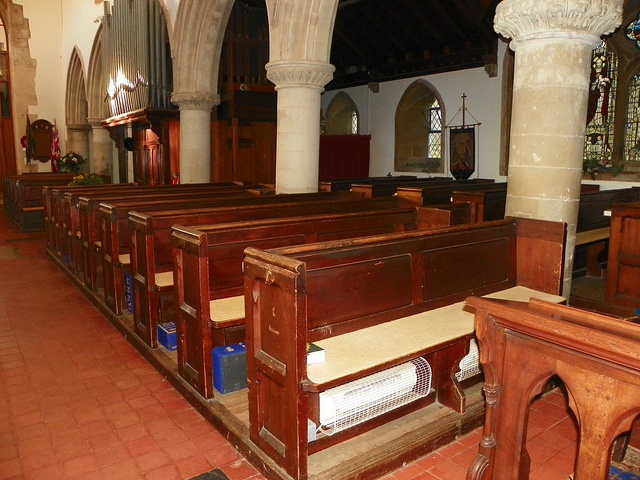Describe the objects in this image and their specific colors. I can see bench in maroon and tan tones, bench in maroon and brown tones, bench in maroon, brown, and tan tones, bench in maroon, black, and tan tones, and bench in maroon and brown tones in this image. 